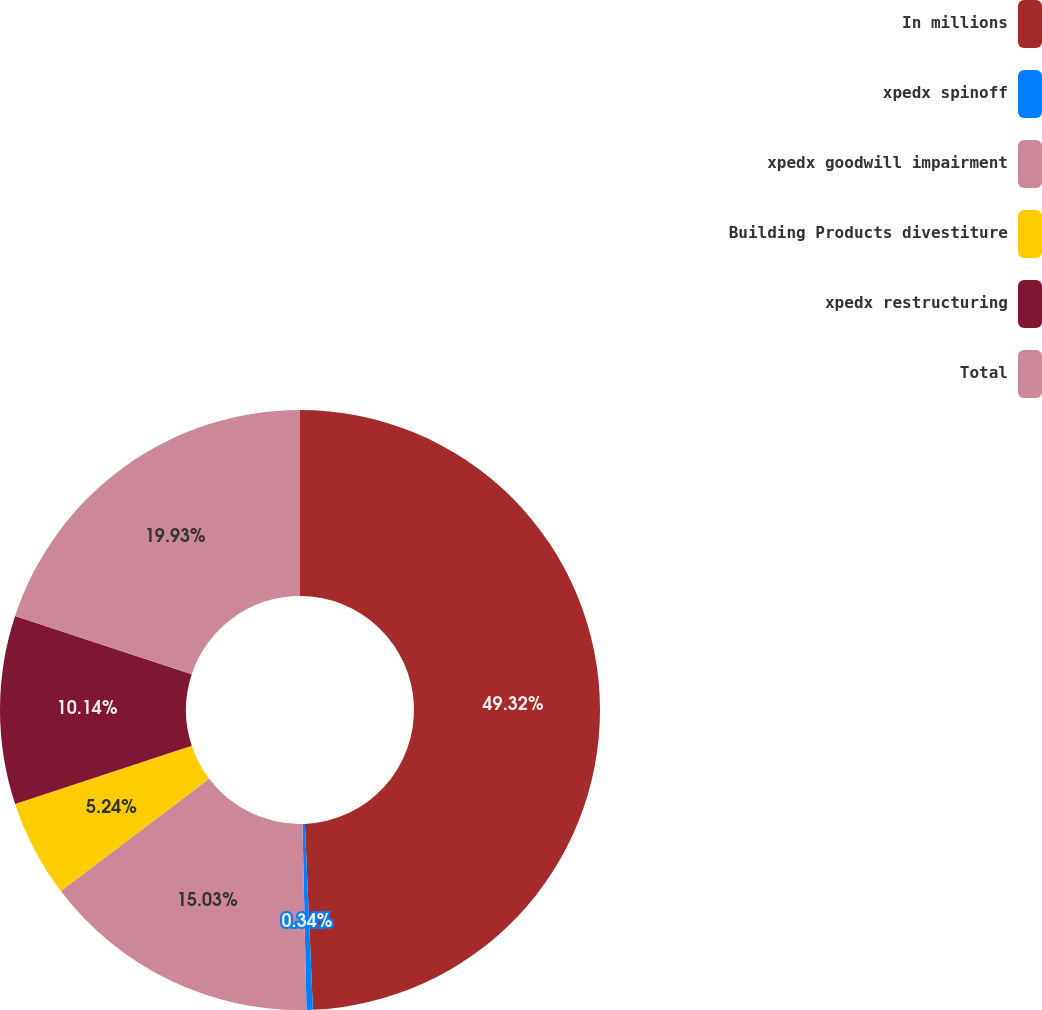Convert chart. <chart><loc_0><loc_0><loc_500><loc_500><pie_chart><fcel>In millions<fcel>xpedx spinoff<fcel>xpedx goodwill impairment<fcel>Building Products divestiture<fcel>xpedx restructuring<fcel>Total<nl><fcel>49.31%<fcel>0.34%<fcel>15.03%<fcel>5.24%<fcel>10.14%<fcel>19.93%<nl></chart> 